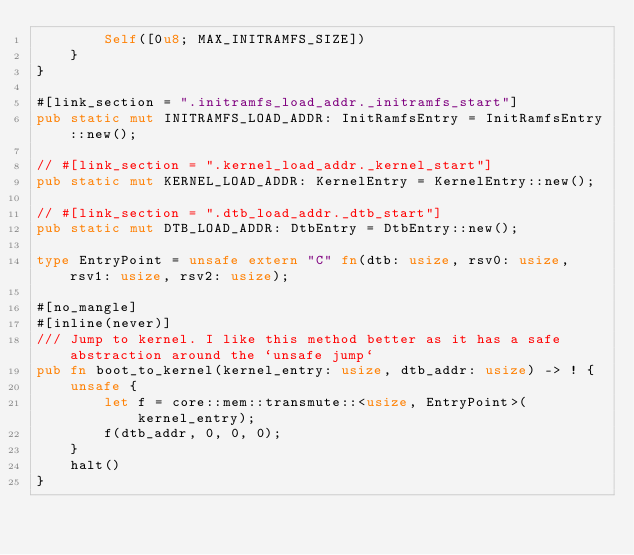Convert code to text. <code><loc_0><loc_0><loc_500><loc_500><_Rust_>        Self([0u8; MAX_INITRAMFS_SIZE])
    }
}

#[link_section = ".initramfs_load_addr._initramfs_start"]
pub static mut INITRAMFS_LOAD_ADDR: InitRamfsEntry = InitRamfsEntry::new();

// #[link_section = ".kernel_load_addr._kernel_start"]
pub static mut KERNEL_LOAD_ADDR: KernelEntry = KernelEntry::new();

// #[link_section = ".dtb_load_addr._dtb_start"]
pub static mut DTB_LOAD_ADDR: DtbEntry = DtbEntry::new();

type EntryPoint = unsafe extern "C" fn(dtb: usize, rsv0: usize, rsv1: usize, rsv2: usize);

#[no_mangle]
#[inline(never)]
/// Jump to kernel. I like this method better as it has a safe abstraction around the `unsafe jump`
pub fn boot_to_kernel(kernel_entry: usize, dtb_addr: usize) -> ! {
    unsafe {
        let f = core::mem::transmute::<usize, EntryPoint>(kernel_entry);
        f(dtb_addr, 0, 0, 0);
    }
    halt()
}
</code> 